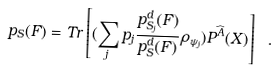<formula> <loc_0><loc_0><loc_500><loc_500>p _ { S } ( F ) = T r \left [ ( \sum _ { j } p _ { j } \frac { p _ { S _ { j } } ^ { d } ( F ) } { p _ { S } ^ { d } ( F ) } \rho _ { \psi _ { j } } ) P ^ { \widehat { A } } ( X ) \right ] \ .</formula> 